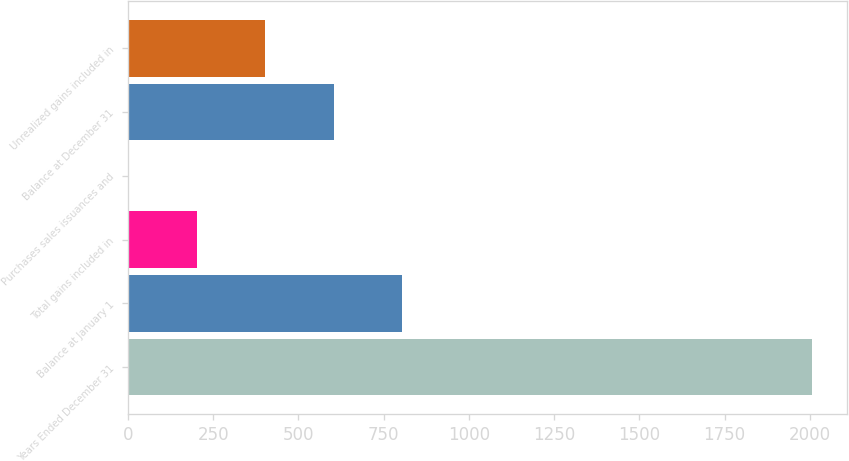Convert chart to OTSL. <chart><loc_0><loc_0><loc_500><loc_500><bar_chart><fcel>Years Ended December 31<fcel>Balance at January 1<fcel>Total gains included in<fcel>Purchases sales issuances and<fcel>Balance at December 31<fcel>Unrealized gains included in<nl><fcel>2008<fcel>803.8<fcel>201.7<fcel>1<fcel>603.1<fcel>402.4<nl></chart> 